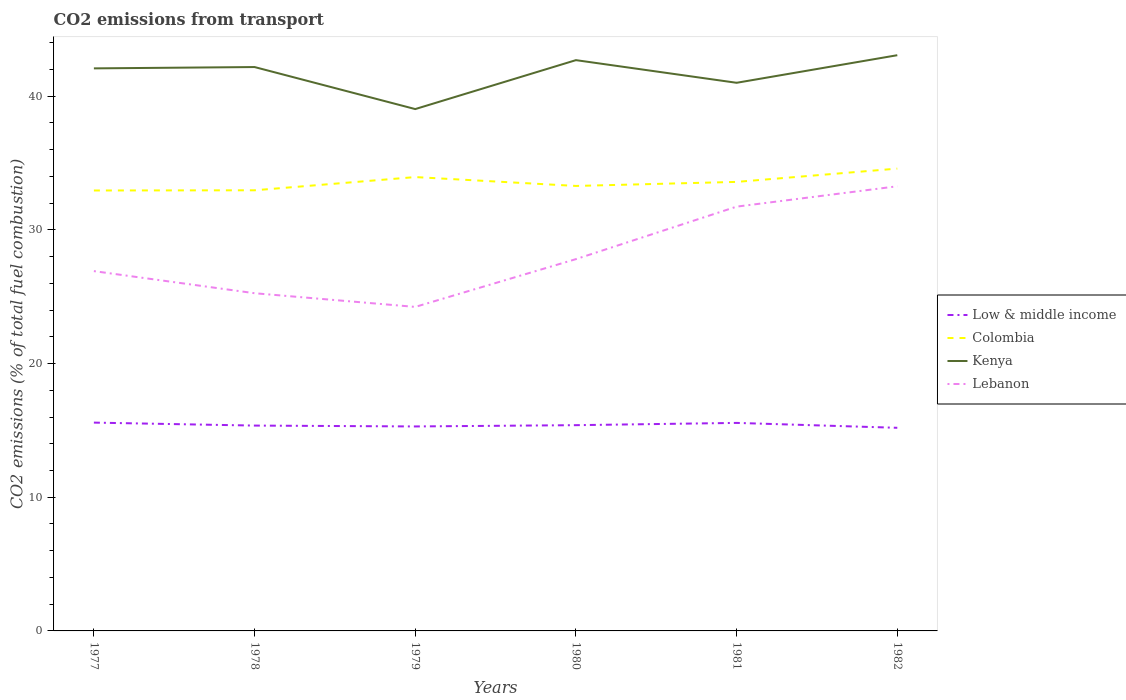Does the line corresponding to Colombia intersect with the line corresponding to Low & middle income?
Keep it short and to the point. No. Is the number of lines equal to the number of legend labels?
Your answer should be very brief. Yes. Across all years, what is the maximum total CO2 emitted in Low & middle income?
Give a very brief answer. 15.19. In which year was the total CO2 emitted in Lebanon maximum?
Offer a terse response. 1979. What is the total total CO2 emitted in Colombia in the graph?
Offer a terse response. -0.99. What is the difference between the highest and the second highest total CO2 emitted in Low & middle income?
Offer a terse response. 0.39. What is the difference between the highest and the lowest total CO2 emitted in Lebanon?
Offer a terse response. 2. How many lines are there?
Ensure brevity in your answer.  4. How many years are there in the graph?
Offer a very short reply. 6. What is the difference between two consecutive major ticks on the Y-axis?
Give a very brief answer. 10. How many legend labels are there?
Keep it short and to the point. 4. How are the legend labels stacked?
Give a very brief answer. Vertical. What is the title of the graph?
Provide a succinct answer. CO2 emissions from transport. Does "Least developed countries" appear as one of the legend labels in the graph?
Offer a very short reply. No. What is the label or title of the Y-axis?
Provide a succinct answer. CO2 emissions (% of total fuel combustion). What is the CO2 emissions (% of total fuel combustion) in Low & middle income in 1977?
Offer a very short reply. 15.58. What is the CO2 emissions (% of total fuel combustion) in Colombia in 1977?
Your answer should be very brief. 32.95. What is the CO2 emissions (% of total fuel combustion) of Kenya in 1977?
Your answer should be compact. 42.08. What is the CO2 emissions (% of total fuel combustion) of Lebanon in 1977?
Your answer should be compact. 26.91. What is the CO2 emissions (% of total fuel combustion) in Low & middle income in 1978?
Your answer should be compact. 15.36. What is the CO2 emissions (% of total fuel combustion) of Colombia in 1978?
Your response must be concise. 32.96. What is the CO2 emissions (% of total fuel combustion) in Kenya in 1978?
Your answer should be very brief. 42.18. What is the CO2 emissions (% of total fuel combustion) of Lebanon in 1978?
Keep it short and to the point. 25.26. What is the CO2 emissions (% of total fuel combustion) of Low & middle income in 1979?
Your response must be concise. 15.3. What is the CO2 emissions (% of total fuel combustion) in Colombia in 1979?
Make the answer very short. 33.95. What is the CO2 emissions (% of total fuel combustion) of Kenya in 1979?
Ensure brevity in your answer.  39.04. What is the CO2 emissions (% of total fuel combustion) in Lebanon in 1979?
Offer a terse response. 24.24. What is the CO2 emissions (% of total fuel combustion) in Low & middle income in 1980?
Your response must be concise. 15.39. What is the CO2 emissions (% of total fuel combustion) in Colombia in 1980?
Keep it short and to the point. 33.29. What is the CO2 emissions (% of total fuel combustion) in Kenya in 1980?
Offer a terse response. 42.7. What is the CO2 emissions (% of total fuel combustion) of Lebanon in 1980?
Give a very brief answer. 27.81. What is the CO2 emissions (% of total fuel combustion) of Low & middle income in 1981?
Your answer should be compact. 15.56. What is the CO2 emissions (% of total fuel combustion) of Colombia in 1981?
Keep it short and to the point. 33.59. What is the CO2 emissions (% of total fuel combustion) of Kenya in 1981?
Your response must be concise. 41. What is the CO2 emissions (% of total fuel combustion) of Lebanon in 1981?
Provide a short and direct response. 31.74. What is the CO2 emissions (% of total fuel combustion) of Low & middle income in 1982?
Your answer should be very brief. 15.19. What is the CO2 emissions (% of total fuel combustion) of Colombia in 1982?
Ensure brevity in your answer.  34.58. What is the CO2 emissions (% of total fuel combustion) in Kenya in 1982?
Your response must be concise. 43.07. What is the CO2 emissions (% of total fuel combustion) in Lebanon in 1982?
Your response must be concise. 33.26. Across all years, what is the maximum CO2 emissions (% of total fuel combustion) of Low & middle income?
Give a very brief answer. 15.58. Across all years, what is the maximum CO2 emissions (% of total fuel combustion) of Colombia?
Ensure brevity in your answer.  34.58. Across all years, what is the maximum CO2 emissions (% of total fuel combustion) in Kenya?
Offer a terse response. 43.07. Across all years, what is the maximum CO2 emissions (% of total fuel combustion) of Lebanon?
Keep it short and to the point. 33.26. Across all years, what is the minimum CO2 emissions (% of total fuel combustion) in Low & middle income?
Your answer should be very brief. 15.19. Across all years, what is the minimum CO2 emissions (% of total fuel combustion) in Colombia?
Ensure brevity in your answer.  32.95. Across all years, what is the minimum CO2 emissions (% of total fuel combustion) in Kenya?
Provide a succinct answer. 39.04. Across all years, what is the minimum CO2 emissions (% of total fuel combustion) in Lebanon?
Make the answer very short. 24.24. What is the total CO2 emissions (% of total fuel combustion) of Low & middle income in the graph?
Offer a very short reply. 92.38. What is the total CO2 emissions (% of total fuel combustion) in Colombia in the graph?
Offer a very short reply. 201.31. What is the total CO2 emissions (% of total fuel combustion) in Kenya in the graph?
Keep it short and to the point. 250.06. What is the total CO2 emissions (% of total fuel combustion) of Lebanon in the graph?
Your answer should be very brief. 169.22. What is the difference between the CO2 emissions (% of total fuel combustion) in Low & middle income in 1977 and that in 1978?
Give a very brief answer. 0.22. What is the difference between the CO2 emissions (% of total fuel combustion) in Colombia in 1977 and that in 1978?
Provide a succinct answer. -0.01. What is the difference between the CO2 emissions (% of total fuel combustion) of Kenya in 1977 and that in 1978?
Offer a terse response. -0.1. What is the difference between the CO2 emissions (% of total fuel combustion) in Lebanon in 1977 and that in 1978?
Provide a succinct answer. 1.65. What is the difference between the CO2 emissions (% of total fuel combustion) in Low & middle income in 1977 and that in 1979?
Your answer should be very brief. 0.29. What is the difference between the CO2 emissions (% of total fuel combustion) in Colombia in 1977 and that in 1979?
Offer a very short reply. -1. What is the difference between the CO2 emissions (% of total fuel combustion) in Kenya in 1977 and that in 1979?
Keep it short and to the point. 3.04. What is the difference between the CO2 emissions (% of total fuel combustion) of Lebanon in 1977 and that in 1979?
Offer a very short reply. 2.68. What is the difference between the CO2 emissions (% of total fuel combustion) in Low & middle income in 1977 and that in 1980?
Give a very brief answer. 0.19. What is the difference between the CO2 emissions (% of total fuel combustion) in Colombia in 1977 and that in 1980?
Your answer should be compact. -0.34. What is the difference between the CO2 emissions (% of total fuel combustion) in Kenya in 1977 and that in 1980?
Ensure brevity in your answer.  -0.62. What is the difference between the CO2 emissions (% of total fuel combustion) in Lebanon in 1977 and that in 1980?
Provide a succinct answer. -0.9. What is the difference between the CO2 emissions (% of total fuel combustion) in Low & middle income in 1977 and that in 1981?
Your answer should be compact. 0.02. What is the difference between the CO2 emissions (% of total fuel combustion) in Colombia in 1977 and that in 1981?
Make the answer very short. -0.64. What is the difference between the CO2 emissions (% of total fuel combustion) of Kenya in 1977 and that in 1981?
Give a very brief answer. 1.08. What is the difference between the CO2 emissions (% of total fuel combustion) in Lebanon in 1977 and that in 1981?
Ensure brevity in your answer.  -4.82. What is the difference between the CO2 emissions (% of total fuel combustion) of Low & middle income in 1977 and that in 1982?
Offer a terse response. 0.39. What is the difference between the CO2 emissions (% of total fuel combustion) of Colombia in 1977 and that in 1982?
Offer a very short reply. -1.64. What is the difference between the CO2 emissions (% of total fuel combustion) of Kenya in 1977 and that in 1982?
Make the answer very short. -0.99. What is the difference between the CO2 emissions (% of total fuel combustion) in Lebanon in 1977 and that in 1982?
Offer a very short reply. -6.35. What is the difference between the CO2 emissions (% of total fuel combustion) of Low & middle income in 1978 and that in 1979?
Provide a succinct answer. 0.06. What is the difference between the CO2 emissions (% of total fuel combustion) in Colombia in 1978 and that in 1979?
Make the answer very short. -0.99. What is the difference between the CO2 emissions (% of total fuel combustion) in Kenya in 1978 and that in 1979?
Your answer should be compact. 3.14. What is the difference between the CO2 emissions (% of total fuel combustion) of Lebanon in 1978 and that in 1979?
Offer a very short reply. 1.02. What is the difference between the CO2 emissions (% of total fuel combustion) in Low & middle income in 1978 and that in 1980?
Provide a short and direct response. -0.03. What is the difference between the CO2 emissions (% of total fuel combustion) of Colombia in 1978 and that in 1980?
Ensure brevity in your answer.  -0.33. What is the difference between the CO2 emissions (% of total fuel combustion) in Kenya in 1978 and that in 1980?
Make the answer very short. -0.52. What is the difference between the CO2 emissions (% of total fuel combustion) of Lebanon in 1978 and that in 1980?
Your answer should be very brief. -2.55. What is the difference between the CO2 emissions (% of total fuel combustion) of Colombia in 1978 and that in 1981?
Your response must be concise. -0.63. What is the difference between the CO2 emissions (% of total fuel combustion) in Kenya in 1978 and that in 1981?
Offer a terse response. 1.18. What is the difference between the CO2 emissions (% of total fuel combustion) in Lebanon in 1978 and that in 1981?
Your answer should be compact. -6.48. What is the difference between the CO2 emissions (% of total fuel combustion) of Low & middle income in 1978 and that in 1982?
Offer a very short reply. 0.17. What is the difference between the CO2 emissions (% of total fuel combustion) in Colombia in 1978 and that in 1982?
Keep it short and to the point. -1.62. What is the difference between the CO2 emissions (% of total fuel combustion) in Kenya in 1978 and that in 1982?
Give a very brief answer. -0.89. What is the difference between the CO2 emissions (% of total fuel combustion) of Lebanon in 1978 and that in 1982?
Ensure brevity in your answer.  -8. What is the difference between the CO2 emissions (% of total fuel combustion) in Low & middle income in 1979 and that in 1980?
Ensure brevity in your answer.  -0.1. What is the difference between the CO2 emissions (% of total fuel combustion) of Colombia in 1979 and that in 1980?
Give a very brief answer. 0.66. What is the difference between the CO2 emissions (% of total fuel combustion) in Kenya in 1979 and that in 1980?
Your answer should be compact. -3.66. What is the difference between the CO2 emissions (% of total fuel combustion) in Lebanon in 1979 and that in 1980?
Keep it short and to the point. -3.57. What is the difference between the CO2 emissions (% of total fuel combustion) of Low & middle income in 1979 and that in 1981?
Give a very brief answer. -0.26. What is the difference between the CO2 emissions (% of total fuel combustion) of Colombia in 1979 and that in 1981?
Your answer should be very brief. 0.36. What is the difference between the CO2 emissions (% of total fuel combustion) of Kenya in 1979 and that in 1981?
Offer a terse response. -1.97. What is the difference between the CO2 emissions (% of total fuel combustion) in Lebanon in 1979 and that in 1981?
Offer a terse response. -7.5. What is the difference between the CO2 emissions (% of total fuel combustion) in Low & middle income in 1979 and that in 1982?
Offer a terse response. 0.1. What is the difference between the CO2 emissions (% of total fuel combustion) of Colombia in 1979 and that in 1982?
Provide a succinct answer. -0.63. What is the difference between the CO2 emissions (% of total fuel combustion) in Kenya in 1979 and that in 1982?
Provide a succinct answer. -4.03. What is the difference between the CO2 emissions (% of total fuel combustion) of Lebanon in 1979 and that in 1982?
Provide a short and direct response. -9.02. What is the difference between the CO2 emissions (% of total fuel combustion) in Low & middle income in 1980 and that in 1981?
Your answer should be very brief. -0.17. What is the difference between the CO2 emissions (% of total fuel combustion) of Colombia in 1980 and that in 1981?
Your response must be concise. -0.3. What is the difference between the CO2 emissions (% of total fuel combustion) in Kenya in 1980 and that in 1981?
Provide a short and direct response. 1.69. What is the difference between the CO2 emissions (% of total fuel combustion) of Lebanon in 1980 and that in 1981?
Offer a terse response. -3.93. What is the difference between the CO2 emissions (% of total fuel combustion) in Low & middle income in 1980 and that in 1982?
Keep it short and to the point. 0.2. What is the difference between the CO2 emissions (% of total fuel combustion) in Colombia in 1980 and that in 1982?
Make the answer very short. -1.3. What is the difference between the CO2 emissions (% of total fuel combustion) in Kenya in 1980 and that in 1982?
Your response must be concise. -0.37. What is the difference between the CO2 emissions (% of total fuel combustion) in Lebanon in 1980 and that in 1982?
Your answer should be compact. -5.45. What is the difference between the CO2 emissions (% of total fuel combustion) of Low & middle income in 1981 and that in 1982?
Offer a terse response. 0.37. What is the difference between the CO2 emissions (% of total fuel combustion) of Colombia in 1981 and that in 1982?
Make the answer very short. -0.99. What is the difference between the CO2 emissions (% of total fuel combustion) of Kenya in 1981 and that in 1982?
Provide a short and direct response. -2.06. What is the difference between the CO2 emissions (% of total fuel combustion) of Lebanon in 1981 and that in 1982?
Keep it short and to the point. -1.52. What is the difference between the CO2 emissions (% of total fuel combustion) of Low & middle income in 1977 and the CO2 emissions (% of total fuel combustion) of Colombia in 1978?
Ensure brevity in your answer.  -17.38. What is the difference between the CO2 emissions (% of total fuel combustion) in Low & middle income in 1977 and the CO2 emissions (% of total fuel combustion) in Kenya in 1978?
Provide a succinct answer. -26.6. What is the difference between the CO2 emissions (% of total fuel combustion) in Low & middle income in 1977 and the CO2 emissions (% of total fuel combustion) in Lebanon in 1978?
Give a very brief answer. -9.68. What is the difference between the CO2 emissions (% of total fuel combustion) of Colombia in 1977 and the CO2 emissions (% of total fuel combustion) of Kenya in 1978?
Offer a terse response. -9.23. What is the difference between the CO2 emissions (% of total fuel combustion) in Colombia in 1977 and the CO2 emissions (% of total fuel combustion) in Lebanon in 1978?
Your response must be concise. 7.68. What is the difference between the CO2 emissions (% of total fuel combustion) of Kenya in 1977 and the CO2 emissions (% of total fuel combustion) of Lebanon in 1978?
Provide a short and direct response. 16.82. What is the difference between the CO2 emissions (% of total fuel combustion) of Low & middle income in 1977 and the CO2 emissions (% of total fuel combustion) of Colombia in 1979?
Make the answer very short. -18.37. What is the difference between the CO2 emissions (% of total fuel combustion) in Low & middle income in 1977 and the CO2 emissions (% of total fuel combustion) in Kenya in 1979?
Your response must be concise. -23.45. What is the difference between the CO2 emissions (% of total fuel combustion) in Low & middle income in 1977 and the CO2 emissions (% of total fuel combustion) in Lebanon in 1979?
Provide a succinct answer. -8.65. What is the difference between the CO2 emissions (% of total fuel combustion) of Colombia in 1977 and the CO2 emissions (% of total fuel combustion) of Kenya in 1979?
Your response must be concise. -6.09. What is the difference between the CO2 emissions (% of total fuel combustion) of Colombia in 1977 and the CO2 emissions (% of total fuel combustion) of Lebanon in 1979?
Ensure brevity in your answer.  8.71. What is the difference between the CO2 emissions (% of total fuel combustion) in Kenya in 1977 and the CO2 emissions (% of total fuel combustion) in Lebanon in 1979?
Keep it short and to the point. 17.84. What is the difference between the CO2 emissions (% of total fuel combustion) of Low & middle income in 1977 and the CO2 emissions (% of total fuel combustion) of Colombia in 1980?
Your response must be concise. -17.7. What is the difference between the CO2 emissions (% of total fuel combustion) of Low & middle income in 1977 and the CO2 emissions (% of total fuel combustion) of Kenya in 1980?
Offer a terse response. -27.11. What is the difference between the CO2 emissions (% of total fuel combustion) of Low & middle income in 1977 and the CO2 emissions (% of total fuel combustion) of Lebanon in 1980?
Make the answer very short. -12.23. What is the difference between the CO2 emissions (% of total fuel combustion) in Colombia in 1977 and the CO2 emissions (% of total fuel combustion) in Kenya in 1980?
Your response must be concise. -9.75. What is the difference between the CO2 emissions (% of total fuel combustion) in Colombia in 1977 and the CO2 emissions (% of total fuel combustion) in Lebanon in 1980?
Provide a succinct answer. 5.13. What is the difference between the CO2 emissions (% of total fuel combustion) of Kenya in 1977 and the CO2 emissions (% of total fuel combustion) of Lebanon in 1980?
Give a very brief answer. 14.27. What is the difference between the CO2 emissions (% of total fuel combustion) of Low & middle income in 1977 and the CO2 emissions (% of total fuel combustion) of Colombia in 1981?
Your answer should be very brief. -18.01. What is the difference between the CO2 emissions (% of total fuel combustion) in Low & middle income in 1977 and the CO2 emissions (% of total fuel combustion) in Kenya in 1981?
Give a very brief answer. -25.42. What is the difference between the CO2 emissions (% of total fuel combustion) in Low & middle income in 1977 and the CO2 emissions (% of total fuel combustion) in Lebanon in 1981?
Your answer should be compact. -16.16. What is the difference between the CO2 emissions (% of total fuel combustion) in Colombia in 1977 and the CO2 emissions (% of total fuel combustion) in Kenya in 1981?
Provide a succinct answer. -8.06. What is the difference between the CO2 emissions (% of total fuel combustion) of Colombia in 1977 and the CO2 emissions (% of total fuel combustion) of Lebanon in 1981?
Provide a succinct answer. 1.21. What is the difference between the CO2 emissions (% of total fuel combustion) in Kenya in 1977 and the CO2 emissions (% of total fuel combustion) in Lebanon in 1981?
Provide a succinct answer. 10.34. What is the difference between the CO2 emissions (% of total fuel combustion) in Low & middle income in 1977 and the CO2 emissions (% of total fuel combustion) in Colombia in 1982?
Give a very brief answer. -19. What is the difference between the CO2 emissions (% of total fuel combustion) of Low & middle income in 1977 and the CO2 emissions (% of total fuel combustion) of Kenya in 1982?
Give a very brief answer. -27.48. What is the difference between the CO2 emissions (% of total fuel combustion) of Low & middle income in 1977 and the CO2 emissions (% of total fuel combustion) of Lebanon in 1982?
Provide a succinct answer. -17.68. What is the difference between the CO2 emissions (% of total fuel combustion) of Colombia in 1977 and the CO2 emissions (% of total fuel combustion) of Kenya in 1982?
Offer a very short reply. -10.12. What is the difference between the CO2 emissions (% of total fuel combustion) of Colombia in 1977 and the CO2 emissions (% of total fuel combustion) of Lebanon in 1982?
Offer a terse response. -0.32. What is the difference between the CO2 emissions (% of total fuel combustion) in Kenya in 1977 and the CO2 emissions (% of total fuel combustion) in Lebanon in 1982?
Provide a short and direct response. 8.82. What is the difference between the CO2 emissions (% of total fuel combustion) of Low & middle income in 1978 and the CO2 emissions (% of total fuel combustion) of Colombia in 1979?
Make the answer very short. -18.59. What is the difference between the CO2 emissions (% of total fuel combustion) of Low & middle income in 1978 and the CO2 emissions (% of total fuel combustion) of Kenya in 1979?
Your answer should be very brief. -23.68. What is the difference between the CO2 emissions (% of total fuel combustion) in Low & middle income in 1978 and the CO2 emissions (% of total fuel combustion) in Lebanon in 1979?
Ensure brevity in your answer.  -8.88. What is the difference between the CO2 emissions (% of total fuel combustion) in Colombia in 1978 and the CO2 emissions (% of total fuel combustion) in Kenya in 1979?
Offer a very short reply. -6.08. What is the difference between the CO2 emissions (% of total fuel combustion) in Colombia in 1978 and the CO2 emissions (% of total fuel combustion) in Lebanon in 1979?
Your answer should be compact. 8.72. What is the difference between the CO2 emissions (% of total fuel combustion) of Kenya in 1978 and the CO2 emissions (% of total fuel combustion) of Lebanon in 1979?
Your answer should be very brief. 17.94. What is the difference between the CO2 emissions (% of total fuel combustion) of Low & middle income in 1978 and the CO2 emissions (% of total fuel combustion) of Colombia in 1980?
Keep it short and to the point. -17.93. What is the difference between the CO2 emissions (% of total fuel combustion) in Low & middle income in 1978 and the CO2 emissions (% of total fuel combustion) in Kenya in 1980?
Keep it short and to the point. -27.34. What is the difference between the CO2 emissions (% of total fuel combustion) of Low & middle income in 1978 and the CO2 emissions (% of total fuel combustion) of Lebanon in 1980?
Offer a very short reply. -12.45. What is the difference between the CO2 emissions (% of total fuel combustion) in Colombia in 1978 and the CO2 emissions (% of total fuel combustion) in Kenya in 1980?
Offer a terse response. -9.74. What is the difference between the CO2 emissions (% of total fuel combustion) of Colombia in 1978 and the CO2 emissions (% of total fuel combustion) of Lebanon in 1980?
Provide a short and direct response. 5.15. What is the difference between the CO2 emissions (% of total fuel combustion) of Kenya in 1978 and the CO2 emissions (% of total fuel combustion) of Lebanon in 1980?
Your response must be concise. 14.37. What is the difference between the CO2 emissions (% of total fuel combustion) in Low & middle income in 1978 and the CO2 emissions (% of total fuel combustion) in Colombia in 1981?
Provide a short and direct response. -18.23. What is the difference between the CO2 emissions (% of total fuel combustion) of Low & middle income in 1978 and the CO2 emissions (% of total fuel combustion) of Kenya in 1981?
Make the answer very short. -25.64. What is the difference between the CO2 emissions (% of total fuel combustion) in Low & middle income in 1978 and the CO2 emissions (% of total fuel combustion) in Lebanon in 1981?
Your response must be concise. -16.38. What is the difference between the CO2 emissions (% of total fuel combustion) in Colombia in 1978 and the CO2 emissions (% of total fuel combustion) in Kenya in 1981?
Give a very brief answer. -8.04. What is the difference between the CO2 emissions (% of total fuel combustion) in Colombia in 1978 and the CO2 emissions (% of total fuel combustion) in Lebanon in 1981?
Your answer should be very brief. 1.22. What is the difference between the CO2 emissions (% of total fuel combustion) in Kenya in 1978 and the CO2 emissions (% of total fuel combustion) in Lebanon in 1981?
Your answer should be compact. 10.44. What is the difference between the CO2 emissions (% of total fuel combustion) in Low & middle income in 1978 and the CO2 emissions (% of total fuel combustion) in Colombia in 1982?
Give a very brief answer. -19.22. What is the difference between the CO2 emissions (% of total fuel combustion) of Low & middle income in 1978 and the CO2 emissions (% of total fuel combustion) of Kenya in 1982?
Provide a short and direct response. -27.71. What is the difference between the CO2 emissions (% of total fuel combustion) in Low & middle income in 1978 and the CO2 emissions (% of total fuel combustion) in Lebanon in 1982?
Keep it short and to the point. -17.9. What is the difference between the CO2 emissions (% of total fuel combustion) in Colombia in 1978 and the CO2 emissions (% of total fuel combustion) in Kenya in 1982?
Offer a terse response. -10.11. What is the difference between the CO2 emissions (% of total fuel combustion) in Colombia in 1978 and the CO2 emissions (% of total fuel combustion) in Lebanon in 1982?
Offer a terse response. -0.3. What is the difference between the CO2 emissions (% of total fuel combustion) of Kenya in 1978 and the CO2 emissions (% of total fuel combustion) of Lebanon in 1982?
Ensure brevity in your answer.  8.92. What is the difference between the CO2 emissions (% of total fuel combustion) in Low & middle income in 1979 and the CO2 emissions (% of total fuel combustion) in Colombia in 1980?
Keep it short and to the point. -17.99. What is the difference between the CO2 emissions (% of total fuel combustion) of Low & middle income in 1979 and the CO2 emissions (% of total fuel combustion) of Kenya in 1980?
Keep it short and to the point. -27.4. What is the difference between the CO2 emissions (% of total fuel combustion) of Low & middle income in 1979 and the CO2 emissions (% of total fuel combustion) of Lebanon in 1980?
Offer a very short reply. -12.52. What is the difference between the CO2 emissions (% of total fuel combustion) of Colombia in 1979 and the CO2 emissions (% of total fuel combustion) of Kenya in 1980?
Ensure brevity in your answer.  -8.75. What is the difference between the CO2 emissions (% of total fuel combustion) of Colombia in 1979 and the CO2 emissions (% of total fuel combustion) of Lebanon in 1980?
Provide a short and direct response. 6.14. What is the difference between the CO2 emissions (% of total fuel combustion) of Kenya in 1979 and the CO2 emissions (% of total fuel combustion) of Lebanon in 1980?
Provide a succinct answer. 11.22. What is the difference between the CO2 emissions (% of total fuel combustion) of Low & middle income in 1979 and the CO2 emissions (% of total fuel combustion) of Colombia in 1981?
Give a very brief answer. -18.29. What is the difference between the CO2 emissions (% of total fuel combustion) of Low & middle income in 1979 and the CO2 emissions (% of total fuel combustion) of Kenya in 1981?
Your answer should be very brief. -25.71. What is the difference between the CO2 emissions (% of total fuel combustion) in Low & middle income in 1979 and the CO2 emissions (% of total fuel combustion) in Lebanon in 1981?
Offer a very short reply. -16.44. What is the difference between the CO2 emissions (% of total fuel combustion) of Colombia in 1979 and the CO2 emissions (% of total fuel combustion) of Kenya in 1981?
Your answer should be very brief. -7.05. What is the difference between the CO2 emissions (% of total fuel combustion) of Colombia in 1979 and the CO2 emissions (% of total fuel combustion) of Lebanon in 1981?
Provide a succinct answer. 2.21. What is the difference between the CO2 emissions (% of total fuel combustion) of Kenya in 1979 and the CO2 emissions (% of total fuel combustion) of Lebanon in 1981?
Offer a terse response. 7.3. What is the difference between the CO2 emissions (% of total fuel combustion) of Low & middle income in 1979 and the CO2 emissions (% of total fuel combustion) of Colombia in 1982?
Ensure brevity in your answer.  -19.29. What is the difference between the CO2 emissions (% of total fuel combustion) in Low & middle income in 1979 and the CO2 emissions (% of total fuel combustion) in Kenya in 1982?
Your response must be concise. -27.77. What is the difference between the CO2 emissions (% of total fuel combustion) in Low & middle income in 1979 and the CO2 emissions (% of total fuel combustion) in Lebanon in 1982?
Provide a short and direct response. -17.97. What is the difference between the CO2 emissions (% of total fuel combustion) of Colombia in 1979 and the CO2 emissions (% of total fuel combustion) of Kenya in 1982?
Your answer should be compact. -9.12. What is the difference between the CO2 emissions (% of total fuel combustion) of Colombia in 1979 and the CO2 emissions (% of total fuel combustion) of Lebanon in 1982?
Ensure brevity in your answer.  0.69. What is the difference between the CO2 emissions (% of total fuel combustion) in Kenya in 1979 and the CO2 emissions (% of total fuel combustion) in Lebanon in 1982?
Your answer should be very brief. 5.77. What is the difference between the CO2 emissions (% of total fuel combustion) of Low & middle income in 1980 and the CO2 emissions (% of total fuel combustion) of Colombia in 1981?
Your response must be concise. -18.2. What is the difference between the CO2 emissions (% of total fuel combustion) of Low & middle income in 1980 and the CO2 emissions (% of total fuel combustion) of Kenya in 1981?
Give a very brief answer. -25.61. What is the difference between the CO2 emissions (% of total fuel combustion) in Low & middle income in 1980 and the CO2 emissions (% of total fuel combustion) in Lebanon in 1981?
Offer a very short reply. -16.35. What is the difference between the CO2 emissions (% of total fuel combustion) in Colombia in 1980 and the CO2 emissions (% of total fuel combustion) in Kenya in 1981?
Make the answer very short. -7.72. What is the difference between the CO2 emissions (% of total fuel combustion) in Colombia in 1980 and the CO2 emissions (% of total fuel combustion) in Lebanon in 1981?
Offer a terse response. 1.55. What is the difference between the CO2 emissions (% of total fuel combustion) in Kenya in 1980 and the CO2 emissions (% of total fuel combustion) in Lebanon in 1981?
Your response must be concise. 10.96. What is the difference between the CO2 emissions (% of total fuel combustion) in Low & middle income in 1980 and the CO2 emissions (% of total fuel combustion) in Colombia in 1982?
Make the answer very short. -19.19. What is the difference between the CO2 emissions (% of total fuel combustion) of Low & middle income in 1980 and the CO2 emissions (% of total fuel combustion) of Kenya in 1982?
Your response must be concise. -27.67. What is the difference between the CO2 emissions (% of total fuel combustion) of Low & middle income in 1980 and the CO2 emissions (% of total fuel combustion) of Lebanon in 1982?
Your answer should be compact. -17.87. What is the difference between the CO2 emissions (% of total fuel combustion) of Colombia in 1980 and the CO2 emissions (% of total fuel combustion) of Kenya in 1982?
Ensure brevity in your answer.  -9.78. What is the difference between the CO2 emissions (% of total fuel combustion) of Colombia in 1980 and the CO2 emissions (% of total fuel combustion) of Lebanon in 1982?
Provide a short and direct response. 0.02. What is the difference between the CO2 emissions (% of total fuel combustion) in Kenya in 1980 and the CO2 emissions (% of total fuel combustion) in Lebanon in 1982?
Offer a terse response. 9.44. What is the difference between the CO2 emissions (% of total fuel combustion) of Low & middle income in 1981 and the CO2 emissions (% of total fuel combustion) of Colombia in 1982?
Your answer should be compact. -19.02. What is the difference between the CO2 emissions (% of total fuel combustion) of Low & middle income in 1981 and the CO2 emissions (% of total fuel combustion) of Kenya in 1982?
Provide a short and direct response. -27.51. What is the difference between the CO2 emissions (% of total fuel combustion) in Low & middle income in 1981 and the CO2 emissions (% of total fuel combustion) in Lebanon in 1982?
Your answer should be very brief. -17.7. What is the difference between the CO2 emissions (% of total fuel combustion) of Colombia in 1981 and the CO2 emissions (% of total fuel combustion) of Kenya in 1982?
Provide a short and direct response. -9.48. What is the difference between the CO2 emissions (% of total fuel combustion) of Colombia in 1981 and the CO2 emissions (% of total fuel combustion) of Lebanon in 1982?
Keep it short and to the point. 0.33. What is the difference between the CO2 emissions (% of total fuel combustion) of Kenya in 1981 and the CO2 emissions (% of total fuel combustion) of Lebanon in 1982?
Offer a very short reply. 7.74. What is the average CO2 emissions (% of total fuel combustion) in Low & middle income per year?
Make the answer very short. 15.4. What is the average CO2 emissions (% of total fuel combustion) in Colombia per year?
Your answer should be very brief. 33.55. What is the average CO2 emissions (% of total fuel combustion) of Kenya per year?
Provide a short and direct response. 41.68. What is the average CO2 emissions (% of total fuel combustion) of Lebanon per year?
Your answer should be very brief. 28.2. In the year 1977, what is the difference between the CO2 emissions (% of total fuel combustion) of Low & middle income and CO2 emissions (% of total fuel combustion) of Colombia?
Ensure brevity in your answer.  -17.36. In the year 1977, what is the difference between the CO2 emissions (% of total fuel combustion) in Low & middle income and CO2 emissions (% of total fuel combustion) in Kenya?
Offer a terse response. -26.5. In the year 1977, what is the difference between the CO2 emissions (% of total fuel combustion) of Low & middle income and CO2 emissions (% of total fuel combustion) of Lebanon?
Keep it short and to the point. -11.33. In the year 1977, what is the difference between the CO2 emissions (% of total fuel combustion) in Colombia and CO2 emissions (% of total fuel combustion) in Kenya?
Your response must be concise. -9.13. In the year 1977, what is the difference between the CO2 emissions (% of total fuel combustion) of Colombia and CO2 emissions (% of total fuel combustion) of Lebanon?
Offer a terse response. 6.03. In the year 1977, what is the difference between the CO2 emissions (% of total fuel combustion) in Kenya and CO2 emissions (% of total fuel combustion) in Lebanon?
Provide a succinct answer. 15.17. In the year 1978, what is the difference between the CO2 emissions (% of total fuel combustion) in Low & middle income and CO2 emissions (% of total fuel combustion) in Colombia?
Keep it short and to the point. -17.6. In the year 1978, what is the difference between the CO2 emissions (% of total fuel combustion) of Low & middle income and CO2 emissions (% of total fuel combustion) of Kenya?
Give a very brief answer. -26.82. In the year 1978, what is the difference between the CO2 emissions (% of total fuel combustion) in Low & middle income and CO2 emissions (% of total fuel combustion) in Lebanon?
Your answer should be very brief. -9.9. In the year 1978, what is the difference between the CO2 emissions (% of total fuel combustion) in Colombia and CO2 emissions (% of total fuel combustion) in Kenya?
Your answer should be very brief. -9.22. In the year 1978, what is the difference between the CO2 emissions (% of total fuel combustion) of Colombia and CO2 emissions (% of total fuel combustion) of Lebanon?
Keep it short and to the point. 7.7. In the year 1978, what is the difference between the CO2 emissions (% of total fuel combustion) of Kenya and CO2 emissions (% of total fuel combustion) of Lebanon?
Make the answer very short. 16.92. In the year 1979, what is the difference between the CO2 emissions (% of total fuel combustion) of Low & middle income and CO2 emissions (% of total fuel combustion) of Colombia?
Your answer should be compact. -18.65. In the year 1979, what is the difference between the CO2 emissions (% of total fuel combustion) of Low & middle income and CO2 emissions (% of total fuel combustion) of Kenya?
Your answer should be compact. -23.74. In the year 1979, what is the difference between the CO2 emissions (% of total fuel combustion) of Low & middle income and CO2 emissions (% of total fuel combustion) of Lebanon?
Your response must be concise. -8.94. In the year 1979, what is the difference between the CO2 emissions (% of total fuel combustion) in Colombia and CO2 emissions (% of total fuel combustion) in Kenya?
Give a very brief answer. -5.09. In the year 1979, what is the difference between the CO2 emissions (% of total fuel combustion) in Colombia and CO2 emissions (% of total fuel combustion) in Lebanon?
Provide a short and direct response. 9.71. In the year 1979, what is the difference between the CO2 emissions (% of total fuel combustion) in Kenya and CO2 emissions (% of total fuel combustion) in Lebanon?
Offer a terse response. 14.8. In the year 1980, what is the difference between the CO2 emissions (% of total fuel combustion) in Low & middle income and CO2 emissions (% of total fuel combustion) in Colombia?
Provide a short and direct response. -17.89. In the year 1980, what is the difference between the CO2 emissions (% of total fuel combustion) of Low & middle income and CO2 emissions (% of total fuel combustion) of Kenya?
Provide a short and direct response. -27.31. In the year 1980, what is the difference between the CO2 emissions (% of total fuel combustion) in Low & middle income and CO2 emissions (% of total fuel combustion) in Lebanon?
Make the answer very short. -12.42. In the year 1980, what is the difference between the CO2 emissions (% of total fuel combustion) of Colombia and CO2 emissions (% of total fuel combustion) of Kenya?
Offer a very short reply. -9.41. In the year 1980, what is the difference between the CO2 emissions (% of total fuel combustion) of Colombia and CO2 emissions (% of total fuel combustion) of Lebanon?
Provide a succinct answer. 5.47. In the year 1980, what is the difference between the CO2 emissions (% of total fuel combustion) of Kenya and CO2 emissions (% of total fuel combustion) of Lebanon?
Make the answer very short. 14.89. In the year 1981, what is the difference between the CO2 emissions (% of total fuel combustion) of Low & middle income and CO2 emissions (% of total fuel combustion) of Colombia?
Ensure brevity in your answer.  -18.03. In the year 1981, what is the difference between the CO2 emissions (% of total fuel combustion) in Low & middle income and CO2 emissions (% of total fuel combustion) in Kenya?
Your answer should be compact. -25.44. In the year 1981, what is the difference between the CO2 emissions (% of total fuel combustion) of Low & middle income and CO2 emissions (% of total fuel combustion) of Lebanon?
Your response must be concise. -16.18. In the year 1981, what is the difference between the CO2 emissions (% of total fuel combustion) in Colombia and CO2 emissions (% of total fuel combustion) in Kenya?
Provide a succinct answer. -7.41. In the year 1981, what is the difference between the CO2 emissions (% of total fuel combustion) of Colombia and CO2 emissions (% of total fuel combustion) of Lebanon?
Ensure brevity in your answer.  1.85. In the year 1981, what is the difference between the CO2 emissions (% of total fuel combustion) of Kenya and CO2 emissions (% of total fuel combustion) of Lebanon?
Make the answer very short. 9.26. In the year 1982, what is the difference between the CO2 emissions (% of total fuel combustion) of Low & middle income and CO2 emissions (% of total fuel combustion) of Colombia?
Make the answer very short. -19.39. In the year 1982, what is the difference between the CO2 emissions (% of total fuel combustion) in Low & middle income and CO2 emissions (% of total fuel combustion) in Kenya?
Offer a very short reply. -27.87. In the year 1982, what is the difference between the CO2 emissions (% of total fuel combustion) of Low & middle income and CO2 emissions (% of total fuel combustion) of Lebanon?
Offer a very short reply. -18.07. In the year 1982, what is the difference between the CO2 emissions (% of total fuel combustion) in Colombia and CO2 emissions (% of total fuel combustion) in Kenya?
Keep it short and to the point. -8.48. In the year 1982, what is the difference between the CO2 emissions (% of total fuel combustion) in Colombia and CO2 emissions (% of total fuel combustion) in Lebanon?
Ensure brevity in your answer.  1.32. In the year 1982, what is the difference between the CO2 emissions (% of total fuel combustion) of Kenya and CO2 emissions (% of total fuel combustion) of Lebanon?
Make the answer very short. 9.8. What is the ratio of the CO2 emissions (% of total fuel combustion) of Low & middle income in 1977 to that in 1978?
Keep it short and to the point. 1.01. What is the ratio of the CO2 emissions (% of total fuel combustion) in Colombia in 1977 to that in 1978?
Offer a terse response. 1. What is the ratio of the CO2 emissions (% of total fuel combustion) of Kenya in 1977 to that in 1978?
Offer a terse response. 1. What is the ratio of the CO2 emissions (% of total fuel combustion) of Lebanon in 1977 to that in 1978?
Provide a short and direct response. 1.07. What is the ratio of the CO2 emissions (% of total fuel combustion) of Low & middle income in 1977 to that in 1979?
Offer a very short reply. 1.02. What is the ratio of the CO2 emissions (% of total fuel combustion) of Colombia in 1977 to that in 1979?
Make the answer very short. 0.97. What is the ratio of the CO2 emissions (% of total fuel combustion) in Kenya in 1977 to that in 1979?
Your answer should be compact. 1.08. What is the ratio of the CO2 emissions (% of total fuel combustion) in Lebanon in 1977 to that in 1979?
Provide a succinct answer. 1.11. What is the ratio of the CO2 emissions (% of total fuel combustion) of Low & middle income in 1977 to that in 1980?
Your answer should be very brief. 1.01. What is the ratio of the CO2 emissions (% of total fuel combustion) of Kenya in 1977 to that in 1980?
Your answer should be very brief. 0.99. What is the ratio of the CO2 emissions (% of total fuel combustion) in Lebanon in 1977 to that in 1980?
Make the answer very short. 0.97. What is the ratio of the CO2 emissions (% of total fuel combustion) of Colombia in 1977 to that in 1981?
Ensure brevity in your answer.  0.98. What is the ratio of the CO2 emissions (% of total fuel combustion) of Kenya in 1977 to that in 1981?
Make the answer very short. 1.03. What is the ratio of the CO2 emissions (% of total fuel combustion) in Lebanon in 1977 to that in 1981?
Your response must be concise. 0.85. What is the ratio of the CO2 emissions (% of total fuel combustion) in Low & middle income in 1977 to that in 1982?
Give a very brief answer. 1.03. What is the ratio of the CO2 emissions (% of total fuel combustion) in Colombia in 1977 to that in 1982?
Offer a terse response. 0.95. What is the ratio of the CO2 emissions (% of total fuel combustion) of Kenya in 1977 to that in 1982?
Your response must be concise. 0.98. What is the ratio of the CO2 emissions (% of total fuel combustion) of Lebanon in 1977 to that in 1982?
Make the answer very short. 0.81. What is the ratio of the CO2 emissions (% of total fuel combustion) of Low & middle income in 1978 to that in 1979?
Your answer should be compact. 1. What is the ratio of the CO2 emissions (% of total fuel combustion) in Colombia in 1978 to that in 1979?
Ensure brevity in your answer.  0.97. What is the ratio of the CO2 emissions (% of total fuel combustion) in Kenya in 1978 to that in 1979?
Offer a very short reply. 1.08. What is the ratio of the CO2 emissions (% of total fuel combustion) of Lebanon in 1978 to that in 1979?
Make the answer very short. 1.04. What is the ratio of the CO2 emissions (% of total fuel combustion) of Colombia in 1978 to that in 1980?
Offer a terse response. 0.99. What is the ratio of the CO2 emissions (% of total fuel combustion) in Kenya in 1978 to that in 1980?
Keep it short and to the point. 0.99. What is the ratio of the CO2 emissions (% of total fuel combustion) in Lebanon in 1978 to that in 1980?
Give a very brief answer. 0.91. What is the ratio of the CO2 emissions (% of total fuel combustion) in Low & middle income in 1978 to that in 1981?
Offer a very short reply. 0.99. What is the ratio of the CO2 emissions (% of total fuel combustion) in Colombia in 1978 to that in 1981?
Your answer should be compact. 0.98. What is the ratio of the CO2 emissions (% of total fuel combustion) in Kenya in 1978 to that in 1981?
Your answer should be compact. 1.03. What is the ratio of the CO2 emissions (% of total fuel combustion) in Lebanon in 1978 to that in 1981?
Ensure brevity in your answer.  0.8. What is the ratio of the CO2 emissions (% of total fuel combustion) of Low & middle income in 1978 to that in 1982?
Your answer should be very brief. 1.01. What is the ratio of the CO2 emissions (% of total fuel combustion) in Colombia in 1978 to that in 1982?
Your response must be concise. 0.95. What is the ratio of the CO2 emissions (% of total fuel combustion) in Kenya in 1978 to that in 1982?
Make the answer very short. 0.98. What is the ratio of the CO2 emissions (% of total fuel combustion) of Lebanon in 1978 to that in 1982?
Give a very brief answer. 0.76. What is the ratio of the CO2 emissions (% of total fuel combustion) of Colombia in 1979 to that in 1980?
Give a very brief answer. 1.02. What is the ratio of the CO2 emissions (% of total fuel combustion) of Kenya in 1979 to that in 1980?
Give a very brief answer. 0.91. What is the ratio of the CO2 emissions (% of total fuel combustion) in Lebanon in 1979 to that in 1980?
Your answer should be compact. 0.87. What is the ratio of the CO2 emissions (% of total fuel combustion) of Colombia in 1979 to that in 1981?
Give a very brief answer. 1.01. What is the ratio of the CO2 emissions (% of total fuel combustion) in Kenya in 1979 to that in 1981?
Your response must be concise. 0.95. What is the ratio of the CO2 emissions (% of total fuel combustion) in Lebanon in 1979 to that in 1981?
Your response must be concise. 0.76. What is the ratio of the CO2 emissions (% of total fuel combustion) of Low & middle income in 1979 to that in 1982?
Give a very brief answer. 1.01. What is the ratio of the CO2 emissions (% of total fuel combustion) of Colombia in 1979 to that in 1982?
Offer a very short reply. 0.98. What is the ratio of the CO2 emissions (% of total fuel combustion) of Kenya in 1979 to that in 1982?
Provide a succinct answer. 0.91. What is the ratio of the CO2 emissions (% of total fuel combustion) in Lebanon in 1979 to that in 1982?
Provide a short and direct response. 0.73. What is the ratio of the CO2 emissions (% of total fuel combustion) in Colombia in 1980 to that in 1981?
Make the answer very short. 0.99. What is the ratio of the CO2 emissions (% of total fuel combustion) in Kenya in 1980 to that in 1981?
Keep it short and to the point. 1.04. What is the ratio of the CO2 emissions (% of total fuel combustion) of Lebanon in 1980 to that in 1981?
Give a very brief answer. 0.88. What is the ratio of the CO2 emissions (% of total fuel combustion) in Colombia in 1980 to that in 1982?
Provide a short and direct response. 0.96. What is the ratio of the CO2 emissions (% of total fuel combustion) of Lebanon in 1980 to that in 1982?
Offer a terse response. 0.84. What is the ratio of the CO2 emissions (% of total fuel combustion) of Low & middle income in 1981 to that in 1982?
Ensure brevity in your answer.  1.02. What is the ratio of the CO2 emissions (% of total fuel combustion) of Colombia in 1981 to that in 1982?
Give a very brief answer. 0.97. What is the ratio of the CO2 emissions (% of total fuel combustion) in Kenya in 1981 to that in 1982?
Keep it short and to the point. 0.95. What is the ratio of the CO2 emissions (% of total fuel combustion) of Lebanon in 1981 to that in 1982?
Your answer should be very brief. 0.95. What is the difference between the highest and the second highest CO2 emissions (% of total fuel combustion) in Low & middle income?
Offer a very short reply. 0.02. What is the difference between the highest and the second highest CO2 emissions (% of total fuel combustion) in Colombia?
Keep it short and to the point. 0.63. What is the difference between the highest and the second highest CO2 emissions (% of total fuel combustion) in Kenya?
Keep it short and to the point. 0.37. What is the difference between the highest and the second highest CO2 emissions (% of total fuel combustion) of Lebanon?
Ensure brevity in your answer.  1.52. What is the difference between the highest and the lowest CO2 emissions (% of total fuel combustion) of Low & middle income?
Your answer should be very brief. 0.39. What is the difference between the highest and the lowest CO2 emissions (% of total fuel combustion) of Colombia?
Offer a terse response. 1.64. What is the difference between the highest and the lowest CO2 emissions (% of total fuel combustion) in Kenya?
Your answer should be compact. 4.03. What is the difference between the highest and the lowest CO2 emissions (% of total fuel combustion) of Lebanon?
Your answer should be compact. 9.02. 